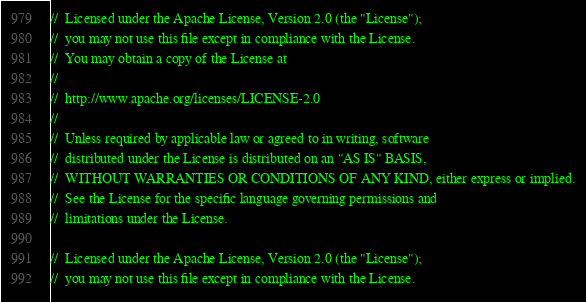Convert code to text. <code><loc_0><loc_0><loc_500><loc_500><_Java_>//  Licensed under the Apache License, Version 2.0 (the "License");
//  you may not use this file except in compliance with the License.
//  You may obtain a copy of the License at
//
//  http://www.apache.org/licenses/LICENSE-2.0
//
//  Unless required by applicable law or agreed to in writing, software
//  distributed under the License is distributed on an "AS IS" BASIS,
//  WITHOUT WARRANTIES OR CONDITIONS OF ANY KIND, either express or implied.
//  See the License for the specific language governing permissions and
//  limitations under the License.

//  Licensed under the Apache License, Version 2.0 (the "License");
//  you may not use this file except in compliance with the License.</code> 